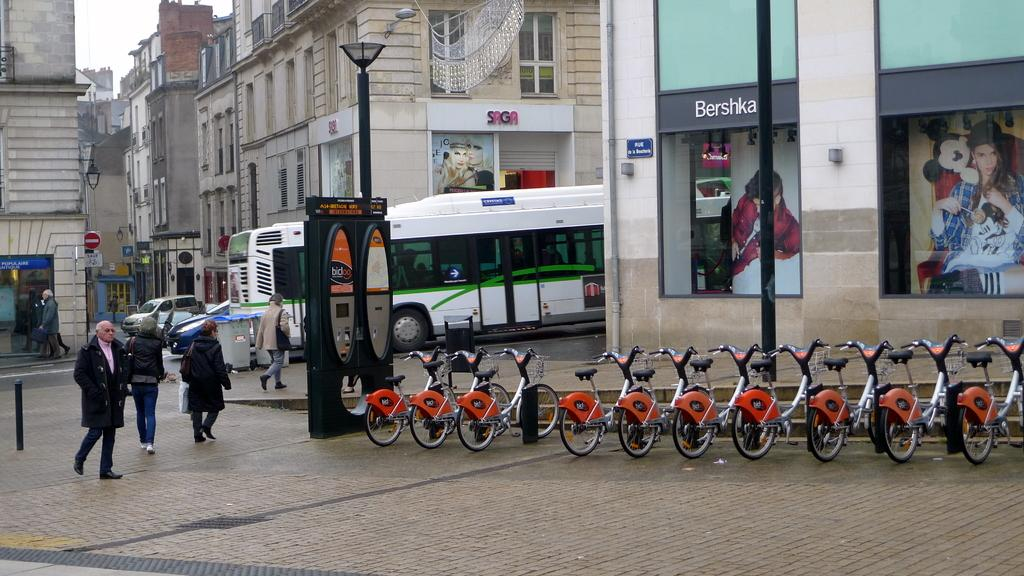<image>
Share a concise interpretation of the image provided. Stores in a city neighborhood have names such as Saga and Bershka. 